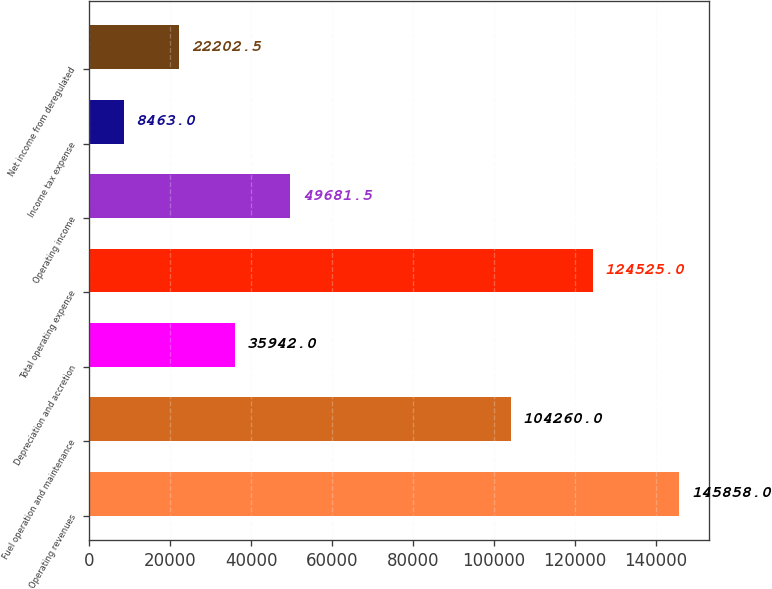Convert chart to OTSL. <chart><loc_0><loc_0><loc_500><loc_500><bar_chart><fcel>Operating revenues<fcel>Fuel operation and maintenance<fcel>Depreciation and accretion<fcel>Total operating expense<fcel>Operating income<fcel>Income tax expense<fcel>Net income from deregulated<nl><fcel>145858<fcel>104260<fcel>35942<fcel>124525<fcel>49681.5<fcel>8463<fcel>22202.5<nl></chart> 